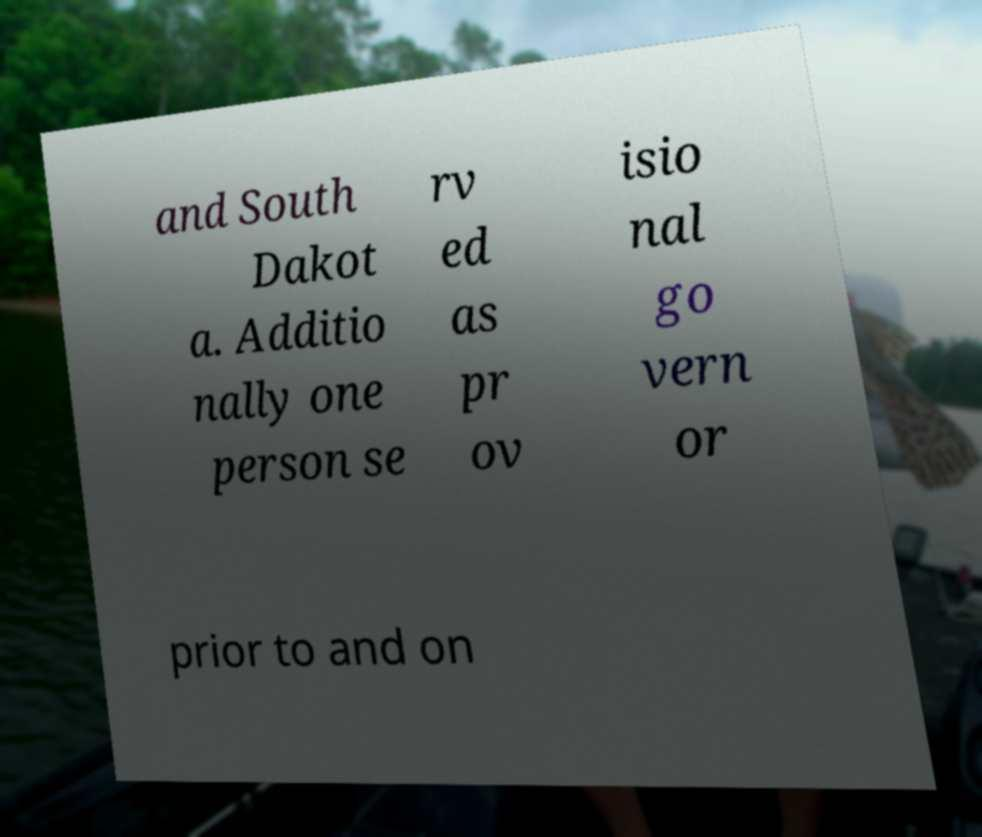Could you extract and type out the text from this image? and South Dakot a. Additio nally one person se rv ed as pr ov isio nal go vern or prior to and on 